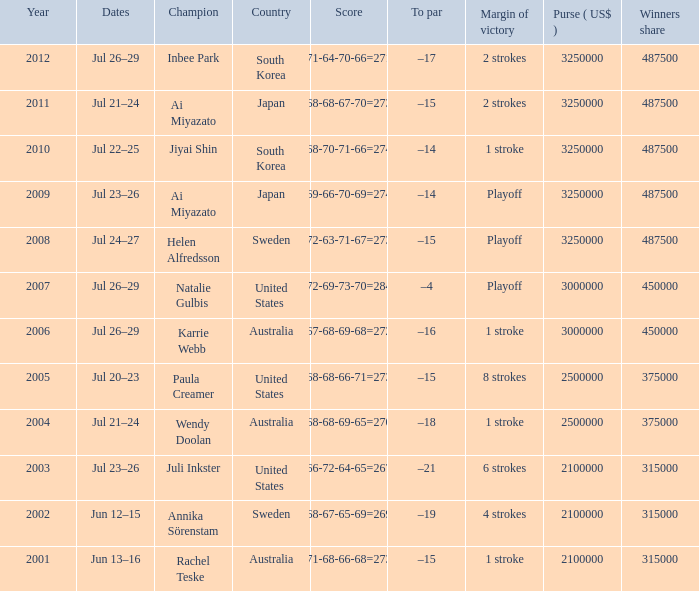How many dollars is the purse when the margin of victory is 8 strokes? 1.0. 